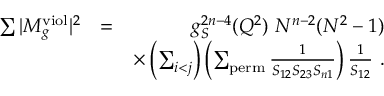Convert formula to latex. <formula><loc_0><loc_0><loc_500><loc_500>\begin{array} { r l r } { \sum | M _ { g } ^ { v i o l } | ^ { 2 } } & { = } & { g _ { S } ^ { 2 n - 4 } ( Q ^ { 2 } ) N ^ { n - 2 } ( N ^ { 2 } - 1 ) } \\ & { \times \left ( \sum _ { i < j } \right ) \left ( \sum _ { p e r m } \frac { 1 } { S _ { 1 2 } S _ { 2 3 } S _ { n 1 } } \right ) \frac { 1 } { S _ { 1 2 } } . } \end{array}</formula> 